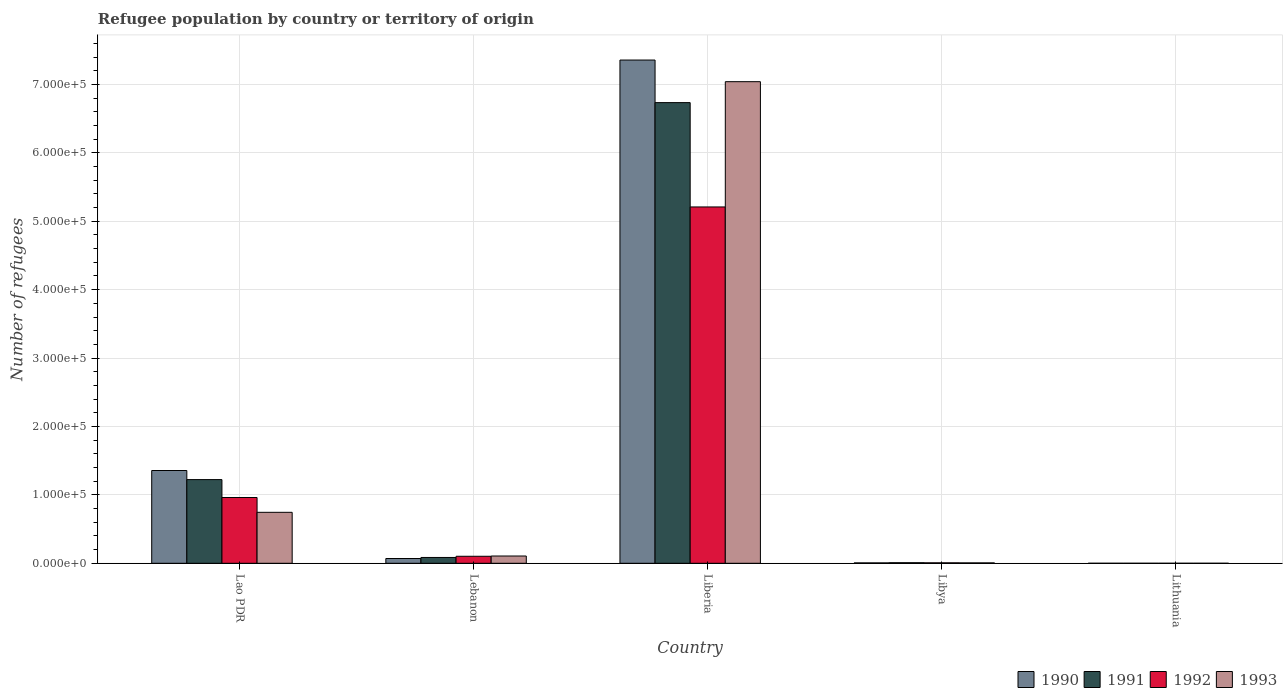How many different coloured bars are there?
Keep it short and to the point. 4. How many groups of bars are there?
Offer a very short reply. 5. Are the number of bars on each tick of the X-axis equal?
Offer a very short reply. Yes. What is the label of the 4th group of bars from the left?
Give a very brief answer. Libya. What is the number of refugees in 1990 in Libya?
Your response must be concise. 581. Across all countries, what is the maximum number of refugees in 1992?
Provide a short and direct response. 5.21e+05. In which country was the number of refugees in 1992 maximum?
Give a very brief answer. Liberia. In which country was the number of refugees in 1991 minimum?
Give a very brief answer. Lithuania. What is the total number of refugees in 1990 in the graph?
Your response must be concise. 8.79e+05. What is the difference between the number of refugees in 1993 in Lao PDR and that in Liberia?
Provide a short and direct response. -6.30e+05. What is the difference between the number of refugees in 1993 in Libya and the number of refugees in 1990 in Lithuania?
Offer a terse response. 593. What is the average number of refugees in 1991 per country?
Make the answer very short. 1.61e+05. What is the difference between the number of refugees of/in 1991 and number of refugees of/in 1992 in Libya?
Give a very brief answer. 154. In how many countries, is the number of refugees in 1992 greater than 260000?
Your answer should be compact. 1. What is the ratio of the number of refugees in 1993 in Lebanon to that in Liberia?
Keep it short and to the point. 0.02. Is the difference between the number of refugees in 1991 in Liberia and Lithuania greater than the difference between the number of refugees in 1992 in Liberia and Lithuania?
Make the answer very short. Yes. What is the difference between the highest and the second highest number of refugees in 1990?
Your response must be concise. -7.29e+05. What is the difference between the highest and the lowest number of refugees in 1991?
Offer a terse response. 6.73e+05. In how many countries, is the number of refugees in 1992 greater than the average number of refugees in 1992 taken over all countries?
Your response must be concise. 1. Is the sum of the number of refugees in 1992 in Lebanon and Libya greater than the maximum number of refugees in 1990 across all countries?
Ensure brevity in your answer.  No. What does the 3rd bar from the right in Lebanon represents?
Keep it short and to the point. 1991. How many bars are there?
Your answer should be compact. 20. Are all the bars in the graph horizontal?
Provide a short and direct response. No. Where does the legend appear in the graph?
Offer a terse response. Bottom right. How are the legend labels stacked?
Give a very brief answer. Horizontal. What is the title of the graph?
Your response must be concise. Refugee population by country or territory of origin. What is the label or title of the X-axis?
Your response must be concise. Country. What is the label or title of the Y-axis?
Keep it short and to the point. Number of refugees. What is the Number of refugees of 1990 in Lao PDR?
Provide a succinct answer. 1.36e+05. What is the Number of refugees in 1991 in Lao PDR?
Ensure brevity in your answer.  1.22e+05. What is the Number of refugees of 1992 in Lao PDR?
Your response must be concise. 9.62e+04. What is the Number of refugees in 1993 in Lao PDR?
Offer a very short reply. 7.45e+04. What is the Number of refugees of 1990 in Lebanon?
Your answer should be compact. 6993. What is the Number of refugees in 1991 in Lebanon?
Give a very brief answer. 8501. What is the Number of refugees of 1992 in Lebanon?
Give a very brief answer. 1.03e+04. What is the Number of refugees of 1993 in Lebanon?
Ensure brevity in your answer.  1.06e+04. What is the Number of refugees in 1990 in Liberia?
Offer a very short reply. 7.36e+05. What is the Number of refugees in 1991 in Liberia?
Your answer should be very brief. 6.73e+05. What is the Number of refugees of 1992 in Liberia?
Provide a succinct answer. 5.21e+05. What is the Number of refugees of 1993 in Liberia?
Give a very brief answer. 7.04e+05. What is the Number of refugees in 1990 in Libya?
Ensure brevity in your answer.  581. What is the Number of refugees of 1991 in Libya?
Give a very brief answer. 840. What is the Number of refugees in 1992 in Libya?
Your answer should be compact. 686. What is the Number of refugees of 1993 in Libya?
Give a very brief answer. 597. What is the Number of refugees of 1991 in Lithuania?
Keep it short and to the point. 4. What is the Number of refugees of 1993 in Lithuania?
Your answer should be compact. 11. Across all countries, what is the maximum Number of refugees of 1990?
Make the answer very short. 7.36e+05. Across all countries, what is the maximum Number of refugees in 1991?
Ensure brevity in your answer.  6.73e+05. Across all countries, what is the maximum Number of refugees in 1992?
Offer a terse response. 5.21e+05. Across all countries, what is the maximum Number of refugees in 1993?
Your response must be concise. 7.04e+05. Across all countries, what is the minimum Number of refugees of 1991?
Your answer should be very brief. 4. Across all countries, what is the minimum Number of refugees in 1993?
Your answer should be compact. 11. What is the total Number of refugees of 1990 in the graph?
Your response must be concise. 8.79e+05. What is the total Number of refugees in 1991 in the graph?
Your answer should be very brief. 8.05e+05. What is the total Number of refugees in 1992 in the graph?
Give a very brief answer. 6.28e+05. What is the total Number of refugees in 1993 in the graph?
Your answer should be compact. 7.90e+05. What is the difference between the Number of refugees of 1990 in Lao PDR and that in Lebanon?
Your answer should be compact. 1.29e+05. What is the difference between the Number of refugees of 1991 in Lao PDR and that in Lebanon?
Provide a succinct answer. 1.14e+05. What is the difference between the Number of refugees in 1992 in Lao PDR and that in Lebanon?
Provide a short and direct response. 8.59e+04. What is the difference between the Number of refugees in 1993 in Lao PDR and that in Lebanon?
Your answer should be compact. 6.39e+04. What is the difference between the Number of refugees in 1990 in Lao PDR and that in Liberia?
Keep it short and to the point. -6.00e+05. What is the difference between the Number of refugees of 1991 in Lao PDR and that in Liberia?
Ensure brevity in your answer.  -5.51e+05. What is the difference between the Number of refugees of 1992 in Lao PDR and that in Liberia?
Provide a short and direct response. -4.25e+05. What is the difference between the Number of refugees in 1993 in Lao PDR and that in Liberia?
Your answer should be very brief. -6.30e+05. What is the difference between the Number of refugees of 1990 in Lao PDR and that in Libya?
Your response must be concise. 1.35e+05. What is the difference between the Number of refugees in 1991 in Lao PDR and that in Libya?
Make the answer very short. 1.21e+05. What is the difference between the Number of refugees of 1992 in Lao PDR and that in Libya?
Give a very brief answer. 9.55e+04. What is the difference between the Number of refugees of 1993 in Lao PDR and that in Libya?
Give a very brief answer. 7.39e+04. What is the difference between the Number of refugees of 1990 in Lao PDR and that in Lithuania?
Keep it short and to the point. 1.36e+05. What is the difference between the Number of refugees of 1991 in Lao PDR and that in Lithuania?
Ensure brevity in your answer.  1.22e+05. What is the difference between the Number of refugees in 1992 in Lao PDR and that in Lithuania?
Your answer should be compact. 9.61e+04. What is the difference between the Number of refugees in 1993 in Lao PDR and that in Lithuania?
Ensure brevity in your answer.  7.45e+04. What is the difference between the Number of refugees in 1990 in Lebanon and that in Liberia?
Provide a succinct answer. -7.29e+05. What is the difference between the Number of refugees of 1991 in Lebanon and that in Liberia?
Your response must be concise. -6.65e+05. What is the difference between the Number of refugees in 1992 in Lebanon and that in Liberia?
Make the answer very short. -5.11e+05. What is the difference between the Number of refugees of 1993 in Lebanon and that in Liberia?
Your answer should be very brief. -6.93e+05. What is the difference between the Number of refugees in 1990 in Lebanon and that in Libya?
Your answer should be compact. 6412. What is the difference between the Number of refugees in 1991 in Lebanon and that in Libya?
Provide a short and direct response. 7661. What is the difference between the Number of refugees in 1992 in Lebanon and that in Libya?
Give a very brief answer. 9571. What is the difference between the Number of refugees in 1993 in Lebanon and that in Libya?
Your answer should be compact. 1.00e+04. What is the difference between the Number of refugees in 1990 in Lebanon and that in Lithuania?
Give a very brief answer. 6989. What is the difference between the Number of refugees in 1991 in Lebanon and that in Lithuania?
Offer a very short reply. 8497. What is the difference between the Number of refugees of 1992 in Lebanon and that in Lithuania?
Keep it short and to the point. 1.02e+04. What is the difference between the Number of refugees of 1993 in Lebanon and that in Lithuania?
Your answer should be very brief. 1.06e+04. What is the difference between the Number of refugees in 1990 in Liberia and that in Libya?
Ensure brevity in your answer.  7.35e+05. What is the difference between the Number of refugees in 1991 in Liberia and that in Libya?
Offer a terse response. 6.73e+05. What is the difference between the Number of refugees in 1992 in Liberia and that in Libya?
Your answer should be compact. 5.20e+05. What is the difference between the Number of refugees in 1993 in Liberia and that in Libya?
Keep it short and to the point. 7.03e+05. What is the difference between the Number of refugees in 1990 in Liberia and that in Lithuania?
Your response must be concise. 7.36e+05. What is the difference between the Number of refugees of 1991 in Liberia and that in Lithuania?
Your answer should be compact. 6.73e+05. What is the difference between the Number of refugees in 1992 in Liberia and that in Lithuania?
Provide a short and direct response. 5.21e+05. What is the difference between the Number of refugees of 1993 in Liberia and that in Lithuania?
Keep it short and to the point. 7.04e+05. What is the difference between the Number of refugees of 1990 in Libya and that in Lithuania?
Provide a succinct answer. 577. What is the difference between the Number of refugees in 1991 in Libya and that in Lithuania?
Your answer should be very brief. 836. What is the difference between the Number of refugees in 1992 in Libya and that in Lithuania?
Provide a short and direct response. 678. What is the difference between the Number of refugees in 1993 in Libya and that in Lithuania?
Keep it short and to the point. 586. What is the difference between the Number of refugees in 1990 in Lao PDR and the Number of refugees in 1991 in Lebanon?
Make the answer very short. 1.27e+05. What is the difference between the Number of refugees of 1990 in Lao PDR and the Number of refugees of 1992 in Lebanon?
Your response must be concise. 1.25e+05. What is the difference between the Number of refugees of 1990 in Lao PDR and the Number of refugees of 1993 in Lebanon?
Your answer should be very brief. 1.25e+05. What is the difference between the Number of refugees of 1991 in Lao PDR and the Number of refugees of 1992 in Lebanon?
Offer a very short reply. 1.12e+05. What is the difference between the Number of refugees in 1991 in Lao PDR and the Number of refugees in 1993 in Lebanon?
Make the answer very short. 1.12e+05. What is the difference between the Number of refugees of 1992 in Lao PDR and the Number of refugees of 1993 in Lebanon?
Keep it short and to the point. 8.55e+04. What is the difference between the Number of refugees of 1990 in Lao PDR and the Number of refugees of 1991 in Liberia?
Your answer should be compact. -5.38e+05. What is the difference between the Number of refugees of 1990 in Lao PDR and the Number of refugees of 1992 in Liberia?
Keep it short and to the point. -3.85e+05. What is the difference between the Number of refugees of 1990 in Lao PDR and the Number of refugees of 1993 in Liberia?
Give a very brief answer. -5.68e+05. What is the difference between the Number of refugees of 1991 in Lao PDR and the Number of refugees of 1992 in Liberia?
Provide a short and direct response. -3.99e+05. What is the difference between the Number of refugees of 1991 in Lao PDR and the Number of refugees of 1993 in Liberia?
Ensure brevity in your answer.  -5.82e+05. What is the difference between the Number of refugees in 1992 in Lao PDR and the Number of refugees in 1993 in Liberia?
Provide a succinct answer. -6.08e+05. What is the difference between the Number of refugees of 1990 in Lao PDR and the Number of refugees of 1991 in Libya?
Offer a terse response. 1.35e+05. What is the difference between the Number of refugees of 1990 in Lao PDR and the Number of refugees of 1992 in Libya?
Give a very brief answer. 1.35e+05. What is the difference between the Number of refugees of 1990 in Lao PDR and the Number of refugees of 1993 in Libya?
Provide a succinct answer. 1.35e+05. What is the difference between the Number of refugees in 1991 in Lao PDR and the Number of refugees in 1992 in Libya?
Give a very brief answer. 1.22e+05. What is the difference between the Number of refugees in 1991 in Lao PDR and the Number of refugees in 1993 in Libya?
Provide a succinct answer. 1.22e+05. What is the difference between the Number of refugees of 1992 in Lao PDR and the Number of refugees of 1993 in Libya?
Your answer should be compact. 9.56e+04. What is the difference between the Number of refugees in 1990 in Lao PDR and the Number of refugees in 1991 in Lithuania?
Your answer should be very brief. 1.36e+05. What is the difference between the Number of refugees of 1990 in Lao PDR and the Number of refugees of 1992 in Lithuania?
Provide a succinct answer. 1.36e+05. What is the difference between the Number of refugees in 1990 in Lao PDR and the Number of refugees in 1993 in Lithuania?
Offer a terse response. 1.36e+05. What is the difference between the Number of refugees of 1991 in Lao PDR and the Number of refugees of 1992 in Lithuania?
Provide a succinct answer. 1.22e+05. What is the difference between the Number of refugees in 1991 in Lao PDR and the Number of refugees in 1993 in Lithuania?
Ensure brevity in your answer.  1.22e+05. What is the difference between the Number of refugees of 1992 in Lao PDR and the Number of refugees of 1993 in Lithuania?
Your answer should be compact. 9.61e+04. What is the difference between the Number of refugees of 1990 in Lebanon and the Number of refugees of 1991 in Liberia?
Your answer should be very brief. -6.66e+05. What is the difference between the Number of refugees in 1990 in Lebanon and the Number of refugees in 1992 in Liberia?
Ensure brevity in your answer.  -5.14e+05. What is the difference between the Number of refugees in 1990 in Lebanon and the Number of refugees in 1993 in Liberia?
Give a very brief answer. -6.97e+05. What is the difference between the Number of refugees in 1991 in Lebanon and the Number of refugees in 1992 in Liberia?
Make the answer very short. -5.12e+05. What is the difference between the Number of refugees in 1991 in Lebanon and the Number of refugees in 1993 in Liberia?
Make the answer very short. -6.96e+05. What is the difference between the Number of refugees of 1992 in Lebanon and the Number of refugees of 1993 in Liberia?
Ensure brevity in your answer.  -6.94e+05. What is the difference between the Number of refugees in 1990 in Lebanon and the Number of refugees in 1991 in Libya?
Offer a terse response. 6153. What is the difference between the Number of refugees of 1990 in Lebanon and the Number of refugees of 1992 in Libya?
Your response must be concise. 6307. What is the difference between the Number of refugees of 1990 in Lebanon and the Number of refugees of 1993 in Libya?
Provide a succinct answer. 6396. What is the difference between the Number of refugees in 1991 in Lebanon and the Number of refugees in 1992 in Libya?
Provide a succinct answer. 7815. What is the difference between the Number of refugees of 1991 in Lebanon and the Number of refugees of 1993 in Libya?
Your answer should be compact. 7904. What is the difference between the Number of refugees of 1992 in Lebanon and the Number of refugees of 1993 in Libya?
Your answer should be very brief. 9660. What is the difference between the Number of refugees of 1990 in Lebanon and the Number of refugees of 1991 in Lithuania?
Provide a short and direct response. 6989. What is the difference between the Number of refugees of 1990 in Lebanon and the Number of refugees of 1992 in Lithuania?
Provide a short and direct response. 6985. What is the difference between the Number of refugees in 1990 in Lebanon and the Number of refugees in 1993 in Lithuania?
Give a very brief answer. 6982. What is the difference between the Number of refugees of 1991 in Lebanon and the Number of refugees of 1992 in Lithuania?
Keep it short and to the point. 8493. What is the difference between the Number of refugees of 1991 in Lebanon and the Number of refugees of 1993 in Lithuania?
Offer a terse response. 8490. What is the difference between the Number of refugees in 1992 in Lebanon and the Number of refugees in 1993 in Lithuania?
Ensure brevity in your answer.  1.02e+04. What is the difference between the Number of refugees in 1990 in Liberia and the Number of refugees in 1991 in Libya?
Provide a succinct answer. 7.35e+05. What is the difference between the Number of refugees of 1990 in Liberia and the Number of refugees of 1992 in Libya?
Provide a succinct answer. 7.35e+05. What is the difference between the Number of refugees in 1990 in Liberia and the Number of refugees in 1993 in Libya?
Make the answer very short. 7.35e+05. What is the difference between the Number of refugees of 1991 in Liberia and the Number of refugees of 1992 in Libya?
Offer a very short reply. 6.73e+05. What is the difference between the Number of refugees in 1991 in Liberia and the Number of refugees in 1993 in Libya?
Your answer should be very brief. 6.73e+05. What is the difference between the Number of refugees in 1992 in Liberia and the Number of refugees in 1993 in Libya?
Your response must be concise. 5.20e+05. What is the difference between the Number of refugees of 1990 in Liberia and the Number of refugees of 1991 in Lithuania?
Provide a succinct answer. 7.36e+05. What is the difference between the Number of refugees of 1990 in Liberia and the Number of refugees of 1992 in Lithuania?
Your response must be concise. 7.36e+05. What is the difference between the Number of refugees in 1990 in Liberia and the Number of refugees in 1993 in Lithuania?
Provide a short and direct response. 7.36e+05. What is the difference between the Number of refugees of 1991 in Liberia and the Number of refugees of 1992 in Lithuania?
Your answer should be compact. 6.73e+05. What is the difference between the Number of refugees of 1991 in Liberia and the Number of refugees of 1993 in Lithuania?
Provide a succinct answer. 6.73e+05. What is the difference between the Number of refugees in 1992 in Liberia and the Number of refugees in 1993 in Lithuania?
Give a very brief answer. 5.21e+05. What is the difference between the Number of refugees of 1990 in Libya and the Number of refugees of 1991 in Lithuania?
Offer a very short reply. 577. What is the difference between the Number of refugees in 1990 in Libya and the Number of refugees in 1992 in Lithuania?
Your response must be concise. 573. What is the difference between the Number of refugees of 1990 in Libya and the Number of refugees of 1993 in Lithuania?
Keep it short and to the point. 570. What is the difference between the Number of refugees in 1991 in Libya and the Number of refugees in 1992 in Lithuania?
Make the answer very short. 832. What is the difference between the Number of refugees of 1991 in Libya and the Number of refugees of 1993 in Lithuania?
Your answer should be very brief. 829. What is the difference between the Number of refugees in 1992 in Libya and the Number of refugees in 1993 in Lithuania?
Ensure brevity in your answer.  675. What is the average Number of refugees in 1990 per country?
Your answer should be compact. 1.76e+05. What is the average Number of refugees in 1991 per country?
Offer a very short reply. 1.61e+05. What is the average Number of refugees in 1992 per country?
Keep it short and to the point. 1.26e+05. What is the average Number of refugees of 1993 per country?
Your response must be concise. 1.58e+05. What is the difference between the Number of refugees of 1990 and Number of refugees of 1991 in Lao PDR?
Ensure brevity in your answer.  1.33e+04. What is the difference between the Number of refugees in 1990 and Number of refugees in 1992 in Lao PDR?
Offer a very short reply. 3.95e+04. What is the difference between the Number of refugees of 1990 and Number of refugees of 1993 in Lao PDR?
Make the answer very short. 6.11e+04. What is the difference between the Number of refugees of 1991 and Number of refugees of 1992 in Lao PDR?
Make the answer very short. 2.62e+04. What is the difference between the Number of refugees of 1991 and Number of refugees of 1993 in Lao PDR?
Offer a very short reply. 4.78e+04. What is the difference between the Number of refugees in 1992 and Number of refugees in 1993 in Lao PDR?
Your answer should be very brief. 2.17e+04. What is the difference between the Number of refugees of 1990 and Number of refugees of 1991 in Lebanon?
Ensure brevity in your answer.  -1508. What is the difference between the Number of refugees in 1990 and Number of refugees in 1992 in Lebanon?
Offer a very short reply. -3264. What is the difference between the Number of refugees of 1990 and Number of refugees of 1993 in Lebanon?
Ensure brevity in your answer.  -3642. What is the difference between the Number of refugees in 1991 and Number of refugees in 1992 in Lebanon?
Offer a very short reply. -1756. What is the difference between the Number of refugees in 1991 and Number of refugees in 1993 in Lebanon?
Provide a succinct answer. -2134. What is the difference between the Number of refugees in 1992 and Number of refugees in 1993 in Lebanon?
Make the answer very short. -378. What is the difference between the Number of refugees of 1990 and Number of refugees of 1991 in Liberia?
Offer a very short reply. 6.23e+04. What is the difference between the Number of refugees of 1990 and Number of refugees of 1992 in Liberia?
Offer a very short reply. 2.15e+05. What is the difference between the Number of refugees of 1990 and Number of refugees of 1993 in Liberia?
Give a very brief answer. 3.16e+04. What is the difference between the Number of refugees in 1991 and Number of refugees in 1992 in Liberia?
Offer a very short reply. 1.53e+05. What is the difference between the Number of refugees of 1991 and Number of refugees of 1993 in Liberia?
Your answer should be very brief. -3.06e+04. What is the difference between the Number of refugees of 1992 and Number of refugees of 1993 in Liberia?
Give a very brief answer. -1.83e+05. What is the difference between the Number of refugees in 1990 and Number of refugees in 1991 in Libya?
Ensure brevity in your answer.  -259. What is the difference between the Number of refugees in 1990 and Number of refugees in 1992 in Libya?
Your answer should be compact. -105. What is the difference between the Number of refugees in 1990 and Number of refugees in 1993 in Libya?
Give a very brief answer. -16. What is the difference between the Number of refugees in 1991 and Number of refugees in 1992 in Libya?
Offer a terse response. 154. What is the difference between the Number of refugees of 1991 and Number of refugees of 1993 in Libya?
Your answer should be very brief. 243. What is the difference between the Number of refugees of 1992 and Number of refugees of 1993 in Libya?
Give a very brief answer. 89. What is the difference between the Number of refugees in 1990 and Number of refugees in 1991 in Lithuania?
Keep it short and to the point. 0. What is the difference between the Number of refugees of 1990 and Number of refugees of 1992 in Lithuania?
Offer a very short reply. -4. What is the difference between the Number of refugees in 1990 and Number of refugees in 1993 in Lithuania?
Your answer should be very brief. -7. What is the difference between the Number of refugees of 1991 and Number of refugees of 1992 in Lithuania?
Offer a very short reply. -4. What is the difference between the Number of refugees of 1992 and Number of refugees of 1993 in Lithuania?
Keep it short and to the point. -3. What is the ratio of the Number of refugees of 1990 in Lao PDR to that in Lebanon?
Make the answer very short. 19.4. What is the ratio of the Number of refugees in 1991 in Lao PDR to that in Lebanon?
Keep it short and to the point. 14.39. What is the ratio of the Number of refugees in 1992 in Lao PDR to that in Lebanon?
Give a very brief answer. 9.37. What is the ratio of the Number of refugees of 1993 in Lao PDR to that in Lebanon?
Provide a succinct answer. 7.01. What is the ratio of the Number of refugees in 1990 in Lao PDR to that in Liberia?
Offer a terse response. 0.18. What is the ratio of the Number of refugees in 1991 in Lao PDR to that in Liberia?
Keep it short and to the point. 0.18. What is the ratio of the Number of refugees in 1992 in Lao PDR to that in Liberia?
Keep it short and to the point. 0.18. What is the ratio of the Number of refugees in 1993 in Lao PDR to that in Liberia?
Offer a terse response. 0.11. What is the ratio of the Number of refugees in 1990 in Lao PDR to that in Libya?
Ensure brevity in your answer.  233.45. What is the ratio of the Number of refugees of 1991 in Lao PDR to that in Libya?
Your response must be concise. 145.63. What is the ratio of the Number of refugees of 1992 in Lao PDR to that in Libya?
Provide a succinct answer. 140.17. What is the ratio of the Number of refugees of 1993 in Lao PDR to that in Libya?
Provide a succinct answer. 124.79. What is the ratio of the Number of refugees in 1990 in Lao PDR to that in Lithuania?
Your answer should be very brief. 3.39e+04. What is the ratio of the Number of refugees of 1991 in Lao PDR to that in Lithuania?
Your response must be concise. 3.06e+04. What is the ratio of the Number of refugees in 1992 in Lao PDR to that in Lithuania?
Ensure brevity in your answer.  1.20e+04. What is the ratio of the Number of refugees of 1993 in Lao PDR to that in Lithuania?
Provide a short and direct response. 6772.82. What is the ratio of the Number of refugees of 1990 in Lebanon to that in Liberia?
Keep it short and to the point. 0.01. What is the ratio of the Number of refugees of 1991 in Lebanon to that in Liberia?
Make the answer very short. 0.01. What is the ratio of the Number of refugees in 1992 in Lebanon to that in Liberia?
Offer a terse response. 0.02. What is the ratio of the Number of refugees of 1993 in Lebanon to that in Liberia?
Offer a terse response. 0.02. What is the ratio of the Number of refugees of 1990 in Lebanon to that in Libya?
Your answer should be compact. 12.04. What is the ratio of the Number of refugees of 1991 in Lebanon to that in Libya?
Ensure brevity in your answer.  10.12. What is the ratio of the Number of refugees of 1992 in Lebanon to that in Libya?
Give a very brief answer. 14.95. What is the ratio of the Number of refugees of 1993 in Lebanon to that in Libya?
Your answer should be compact. 17.81. What is the ratio of the Number of refugees of 1990 in Lebanon to that in Lithuania?
Make the answer very short. 1748.25. What is the ratio of the Number of refugees of 1991 in Lebanon to that in Lithuania?
Give a very brief answer. 2125.25. What is the ratio of the Number of refugees of 1992 in Lebanon to that in Lithuania?
Keep it short and to the point. 1282.12. What is the ratio of the Number of refugees in 1993 in Lebanon to that in Lithuania?
Give a very brief answer. 966.82. What is the ratio of the Number of refugees in 1990 in Liberia to that in Libya?
Keep it short and to the point. 1266.25. What is the ratio of the Number of refugees in 1991 in Liberia to that in Libya?
Make the answer very short. 801.71. What is the ratio of the Number of refugees of 1992 in Liberia to that in Libya?
Make the answer very short. 759.35. What is the ratio of the Number of refugees in 1993 in Liberia to that in Libya?
Make the answer very short. 1179.31. What is the ratio of the Number of refugees of 1990 in Liberia to that in Lithuania?
Your answer should be very brief. 1.84e+05. What is the ratio of the Number of refugees in 1991 in Liberia to that in Lithuania?
Your response must be concise. 1.68e+05. What is the ratio of the Number of refugees of 1992 in Liberia to that in Lithuania?
Ensure brevity in your answer.  6.51e+04. What is the ratio of the Number of refugees of 1993 in Liberia to that in Lithuania?
Your answer should be very brief. 6.40e+04. What is the ratio of the Number of refugees of 1990 in Libya to that in Lithuania?
Offer a terse response. 145.25. What is the ratio of the Number of refugees of 1991 in Libya to that in Lithuania?
Give a very brief answer. 210. What is the ratio of the Number of refugees of 1992 in Libya to that in Lithuania?
Make the answer very short. 85.75. What is the ratio of the Number of refugees in 1993 in Libya to that in Lithuania?
Offer a terse response. 54.27. What is the difference between the highest and the second highest Number of refugees of 1990?
Provide a succinct answer. 6.00e+05. What is the difference between the highest and the second highest Number of refugees in 1991?
Make the answer very short. 5.51e+05. What is the difference between the highest and the second highest Number of refugees in 1992?
Your response must be concise. 4.25e+05. What is the difference between the highest and the second highest Number of refugees in 1993?
Make the answer very short. 6.30e+05. What is the difference between the highest and the lowest Number of refugees of 1990?
Ensure brevity in your answer.  7.36e+05. What is the difference between the highest and the lowest Number of refugees in 1991?
Keep it short and to the point. 6.73e+05. What is the difference between the highest and the lowest Number of refugees in 1992?
Your response must be concise. 5.21e+05. What is the difference between the highest and the lowest Number of refugees in 1993?
Offer a terse response. 7.04e+05. 